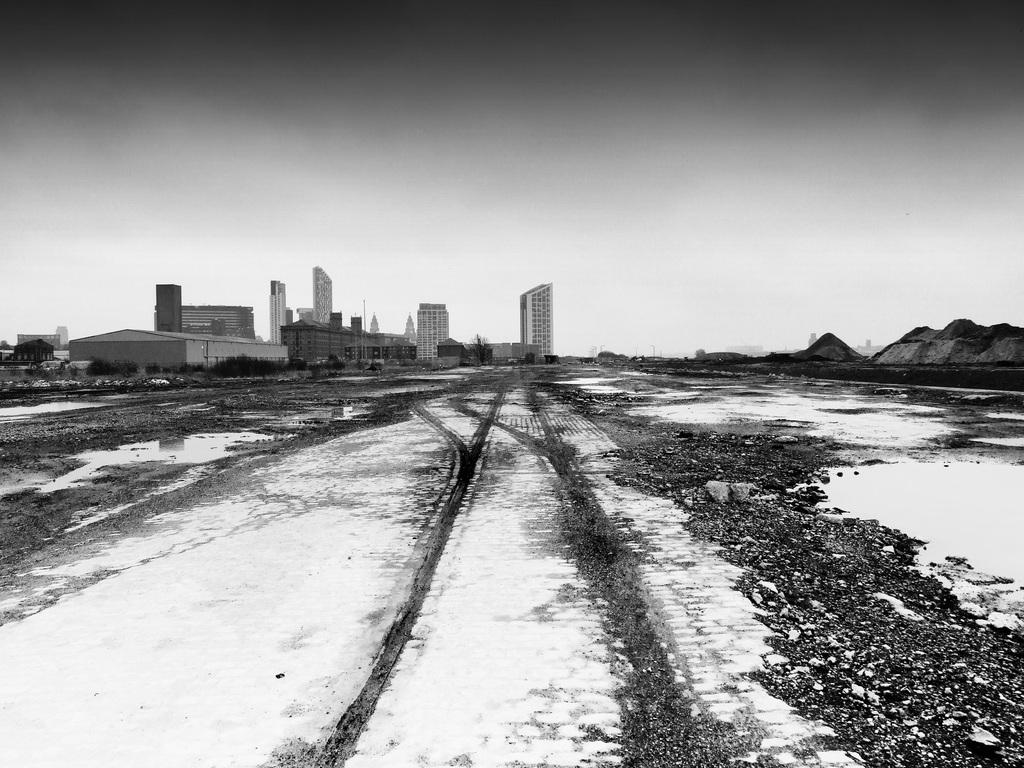What is the color scheme of the image? The image is black and white. What can be seen at the bottom of the image? There is a land at the bottom of the image. What type of structures are visible in the background? There are buildings in the background of the image. What is visible at the top of the image? The sky is visible at the top of the image. Can you tell me how many ducks are flying in the sky in the image? There are no ducks present in the image; it is a black and white image with land, buildings, and sky. What type of pie is being served in the image? There is no pie present in the image. 